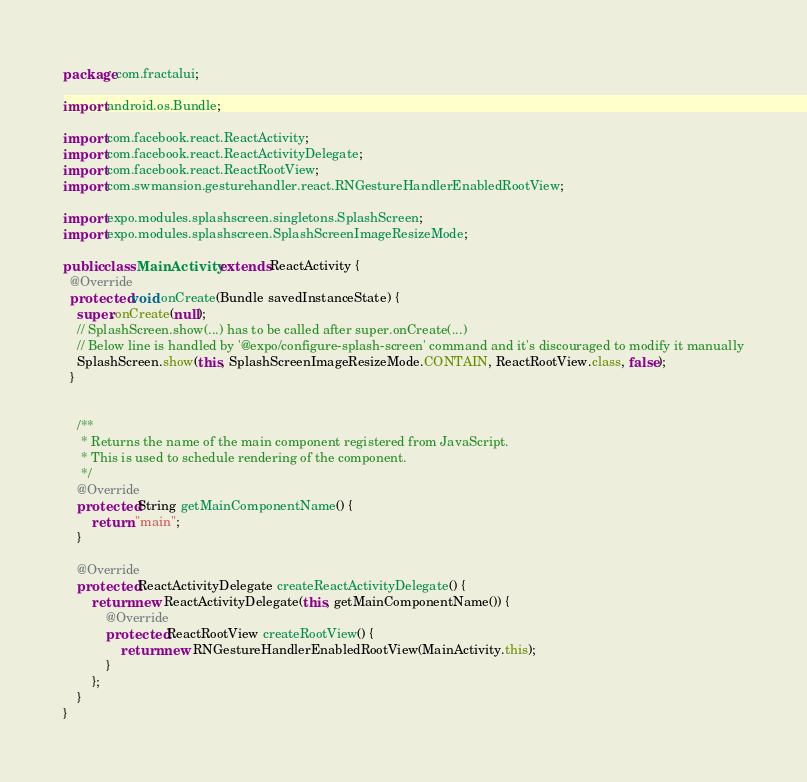<code> <loc_0><loc_0><loc_500><loc_500><_Java_>package com.fractalui;

import android.os.Bundle;

import com.facebook.react.ReactActivity;
import com.facebook.react.ReactActivityDelegate;
import com.facebook.react.ReactRootView;
import com.swmansion.gesturehandler.react.RNGestureHandlerEnabledRootView;

import expo.modules.splashscreen.singletons.SplashScreen;
import expo.modules.splashscreen.SplashScreenImageResizeMode;

public class MainActivity extends ReactActivity {
  @Override
  protected void onCreate(Bundle savedInstanceState) {
    super.onCreate(null);
    // SplashScreen.show(...) has to be called after super.onCreate(...)
    // Below line is handled by '@expo/configure-splash-screen' command and it's discouraged to modify it manually
    SplashScreen.show(this, SplashScreenImageResizeMode.CONTAIN, ReactRootView.class, false);
  }


    /**
     * Returns the name of the main component registered from JavaScript.
     * This is used to schedule rendering of the component.
     */
    @Override
    protected String getMainComponentName() {
        return "main";
    }

    @Override
    protected ReactActivityDelegate createReactActivityDelegate() {
        return new ReactActivityDelegate(this, getMainComponentName()) {
            @Override
            protected ReactRootView createRootView() {
                return new RNGestureHandlerEnabledRootView(MainActivity.this);
            }
        };
    }
}
</code> 